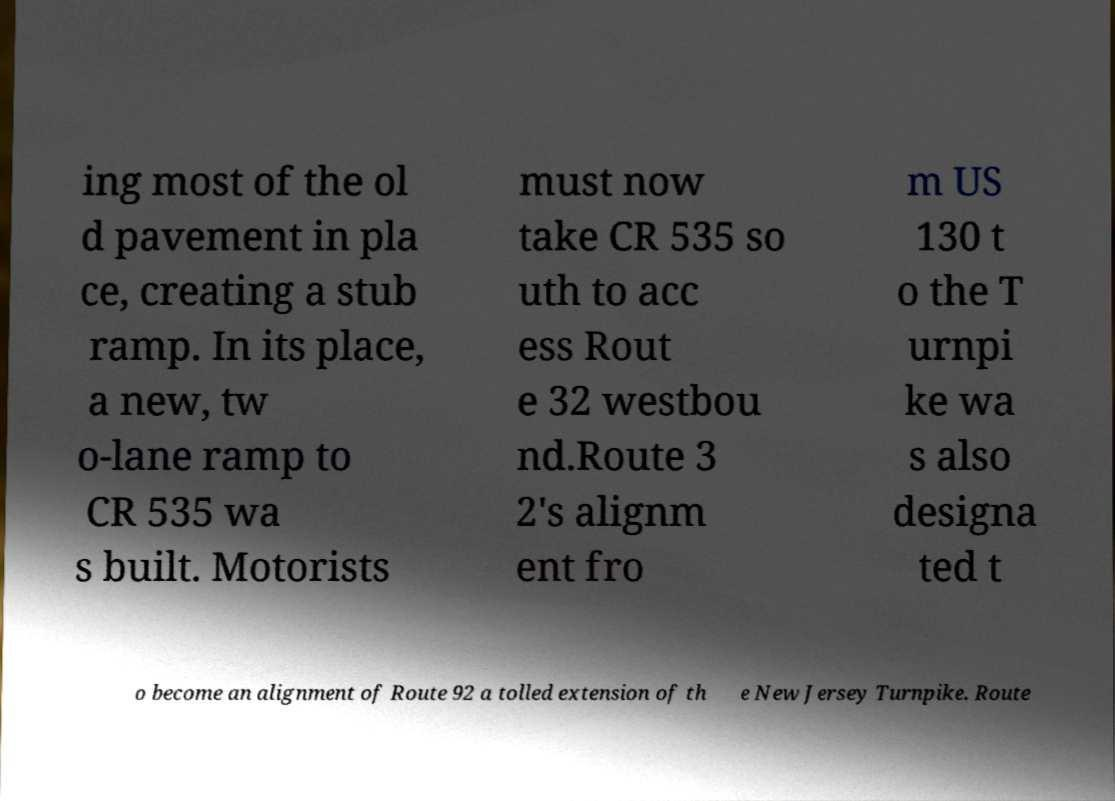There's text embedded in this image that I need extracted. Can you transcribe it verbatim? ing most of the ol d pavement in pla ce, creating a stub ramp. In its place, a new, tw o-lane ramp to CR 535 wa s built. Motorists must now take CR 535 so uth to acc ess Rout e 32 westbou nd.Route 3 2's alignm ent fro m US 130 t o the T urnpi ke wa s also designa ted t o become an alignment of Route 92 a tolled extension of th e New Jersey Turnpike. Route 